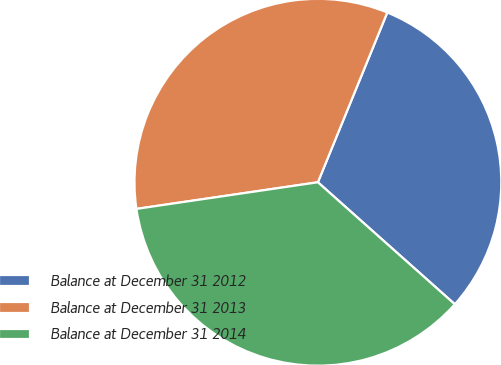Convert chart. <chart><loc_0><loc_0><loc_500><loc_500><pie_chart><fcel>Balance at December 31 2012<fcel>Balance at December 31 2013<fcel>Balance at December 31 2014<nl><fcel>30.41%<fcel>33.5%<fcel>36.1%<nl></chart> 